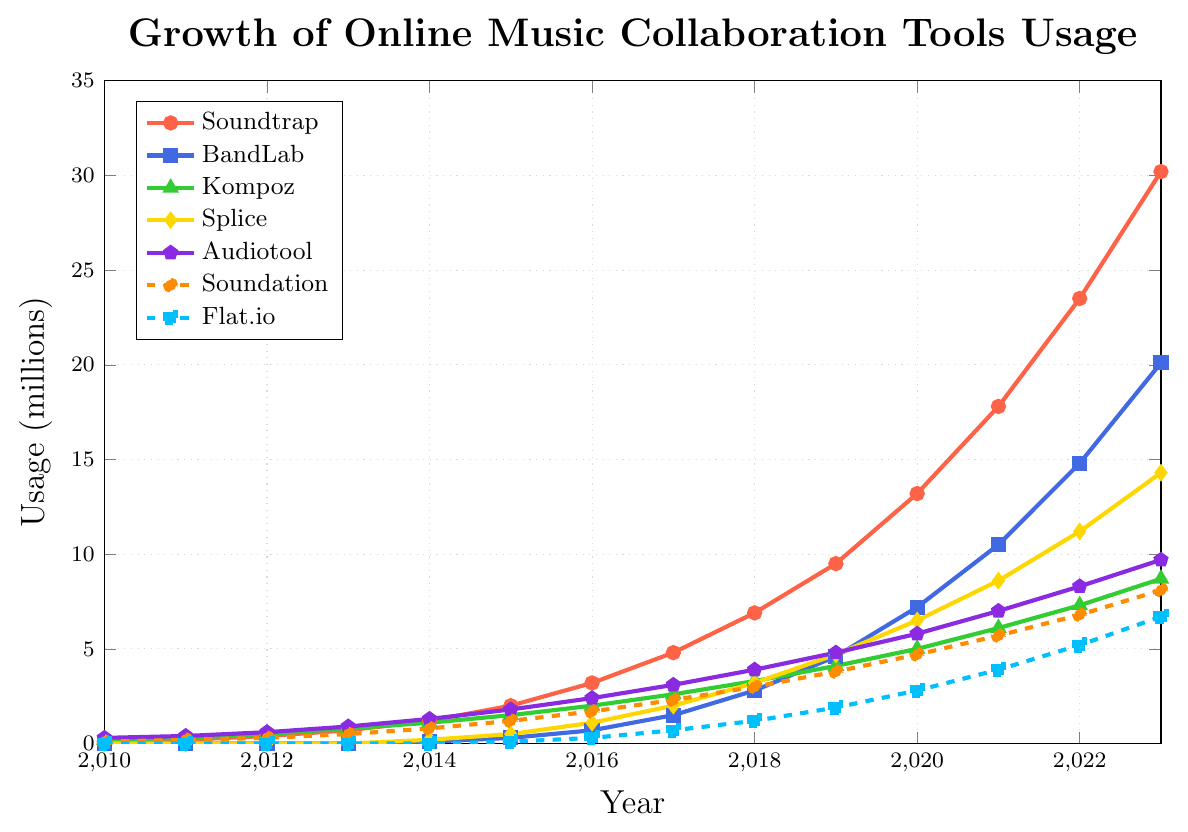Which tool had the highest usage in 2023? To find the answer, look at the highest point on the y-axis for the year 2023 and observe which tool it corresponds to. The highest value is for Soundtrap.
Answer: Soundtrap How much did BandLab's usage grow from 2014 to 2020? Subtract BandLab’s usage in 2014 from its usage in 2020. It grew from 0.1 million in 2014 to 7.2 million in 2020. The difference is 7.2 - 0.1 = 7.1 million.
Answer: 7.1 million Which tool showed the least growth between 2016 and 2017? By examining the slopes of the lines between 2016 and 2017, the smallest increase in y-values indicates the least growth. Kompoz increased from 2.0 to 2.6 which is the smallest change.
Answer: Kompoz What is the average usage of Audiotool from 2010 to 2023? Sum the usage values of Audiotool from 2010 to 2023 and divide by the number of years. (0.3 + 0.4 + 0.6 + 0.9 + 1.3 + 1.8 + 2.4 + 3.1 + 3.9 + 4.8 + 5.8 + 7.0 + 8.3 + 9.7) / 14 equals (49.3 / 14) ≈ 3.52 million.
Answer: 3.52 million Which two tools had equal usage in 2010? Look for tools that have the same y-value in 2010. Soundtrap and Soundation both had a usage of 0.1 million.
Answer: Soundtrap and Soundation In which year did Splice's usage first reach 1 million? Trace the y-value for Splice to find the first year it is equal to or exceeds 1 million. In 2016, Splice's usage was 1.1 million.
Answer: 2016 Which tool had a higher usage in 2023, Soundation or Flat.io? Compare the y-values for Soundation and Flat.io in 2023. Soundation had 8.1 million and Flat.io had 6.7 million, so Soundation is higher.
Answer: Soundation How much more did Soundtrap's usage increase compared to Kompoz from 2010 to 2023? Calculate the difference in usage increase for each tool from 2010 to 2023 and then find the difference between these values. Soundtrap: 30.2 - 0.1 = 30.1 million, Kompoz: 8.7 - 0.2 = 8.5 million. The difference is 30.1 - 8.5 = 21.6 million.
Answer: 21.6 million Which tool had the steepest growth curve between 2022 and 2023? Identify the tool with the steepest or most sharply rising line segment between 2022 and 2023. Soundtrap increased from 23.5 to 30.2 million, which is a 6.7 million increase, indicating the steepest growth.
Answer: Soundtrap 